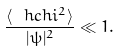Convert formula to latex. <formula><loc_0><loc_0><loc_500><loc_500>\frac { \langle \ h c h i ^ { 2 } \rangle } { | \psi | ^ { 2 } } \ll 1 .</formula> 